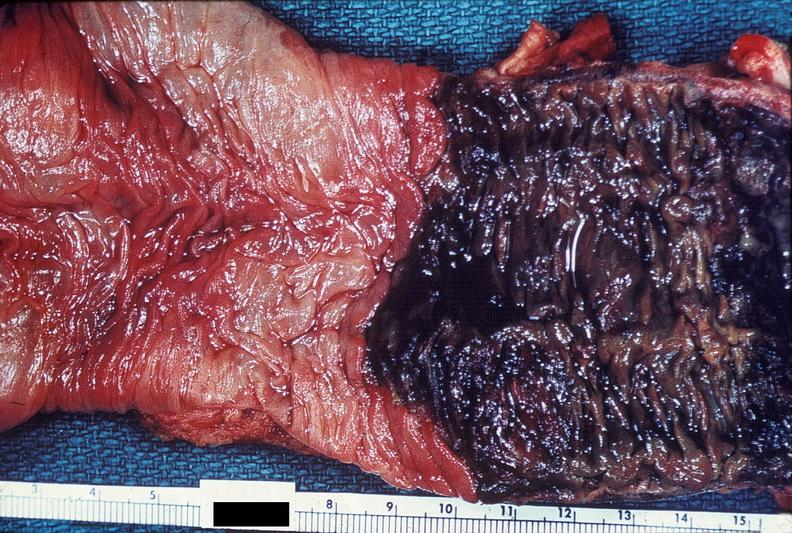s optic nerve present?
Answer the question using a single word or phrase. No 